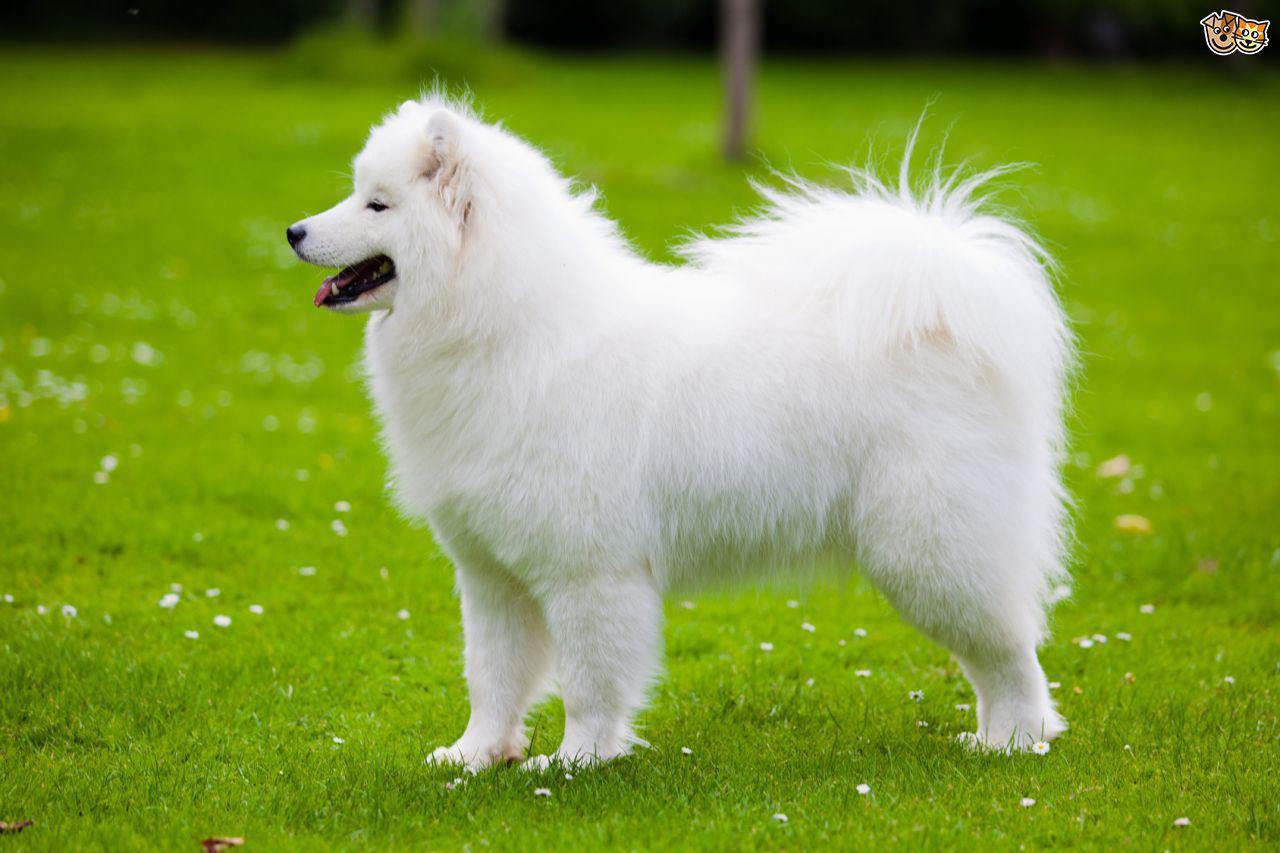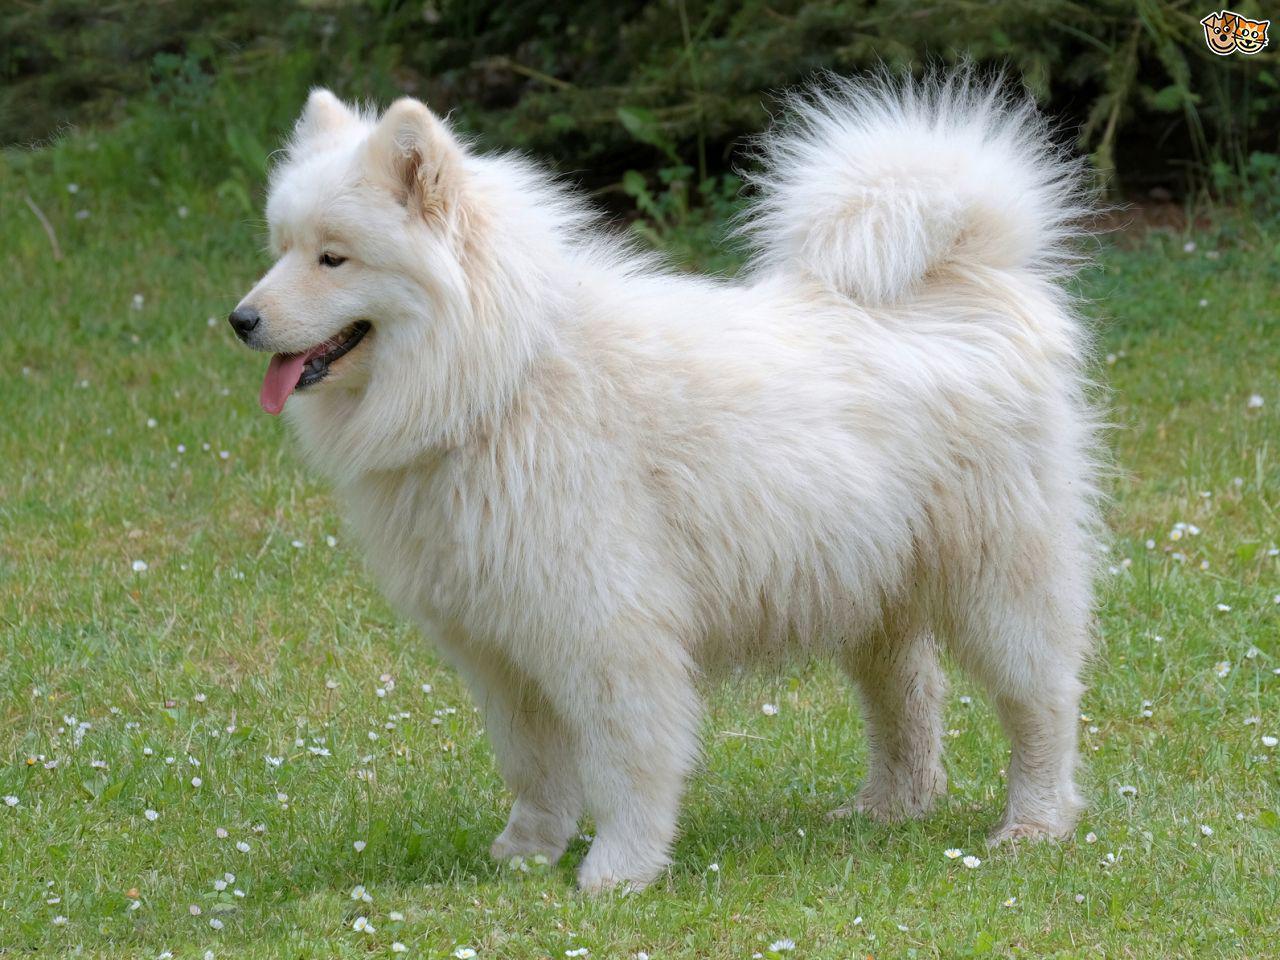The first image is the image on the left, the second image is the image on the right. Given the left and right images, does the statement "There are two white dogs standing outside." hold true? Answer yes or no. Yes. The first image is the image on the left, the second image is the image on the right. Considering the images on both sides, is "One image features one or more white dogs reclining on grass." valid? Answer yes or no. No. The first image is the image on the left, the second image is the image on the right. Examine the images to the left and right. Is the description "The dogs have their mouths open." accurate? Answer yes or no. Yes. The first image is the image on the left, the second image is the image on the right. Considering the images on both sides, is "The dog on the right is facing right." valid? Answer yes or no. No. 